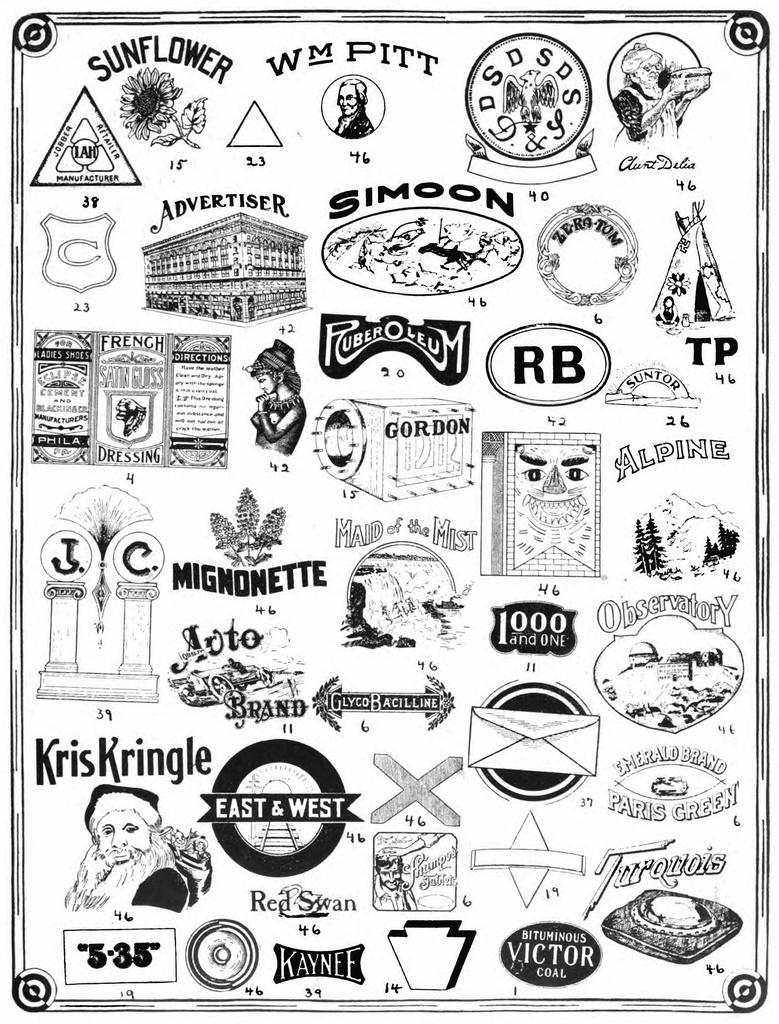What type of visual elements can be seen in the image? There are arts, symbols, and text in the image. Can you describe the symbols in the image? Unfortunately, the specific symbols cannot be described without more information about their appearance. What is the purpose of the text in the image? The purpose of the text in the image cannot be determined without more context. Where is the monkey sitting on the quilt in the image? There is no monkey or quilt present in the image. How many stars are visible in the image? There is no mention of stars in the image, so it cannot be determined how many are visible. 